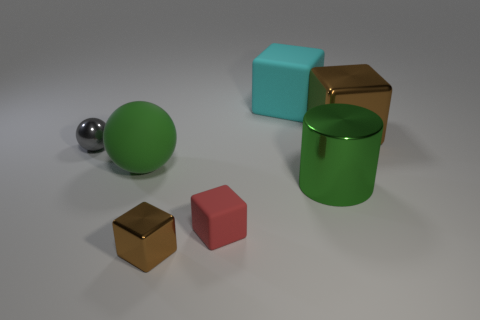Subtract 1 blocks. How many blocks are left? 3 Add 3 metallic balls. How many objects exist? 10 Subtract all balls. How many objects are left? 5 Subtract all large brown metallic objects. Subtract all rubber blocks. How many objects are left? 4 Add 5 green things. How many green things are left? 7 Add 5 tiny red objects. How many tiny red objects exist? 6 Subtract 1 cyan blocks. How many objects are left? 6 